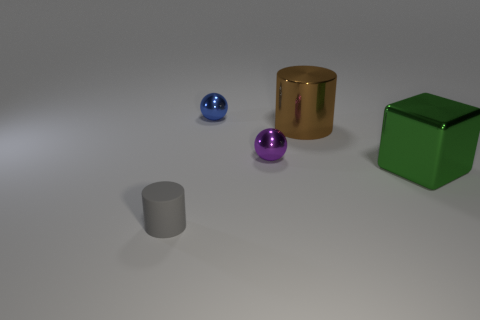Subtract all blue cylinders. Subtract all green blocks. How many cylinders are left? 2 Add 5 small gray cylinders. How many objects exist? 10 Subtract all spheres. How many objects are left? 3 Subtract all purple metal objects. Subtract all shiny objects. How many objects are left? 0 Add 2 blue metal balls. How many blue metal balls are left? 3 Add 2 tiny green balls. How many tiny green balls exist? 2 Subtract 0 brown blocks. How many objects are left? 5 